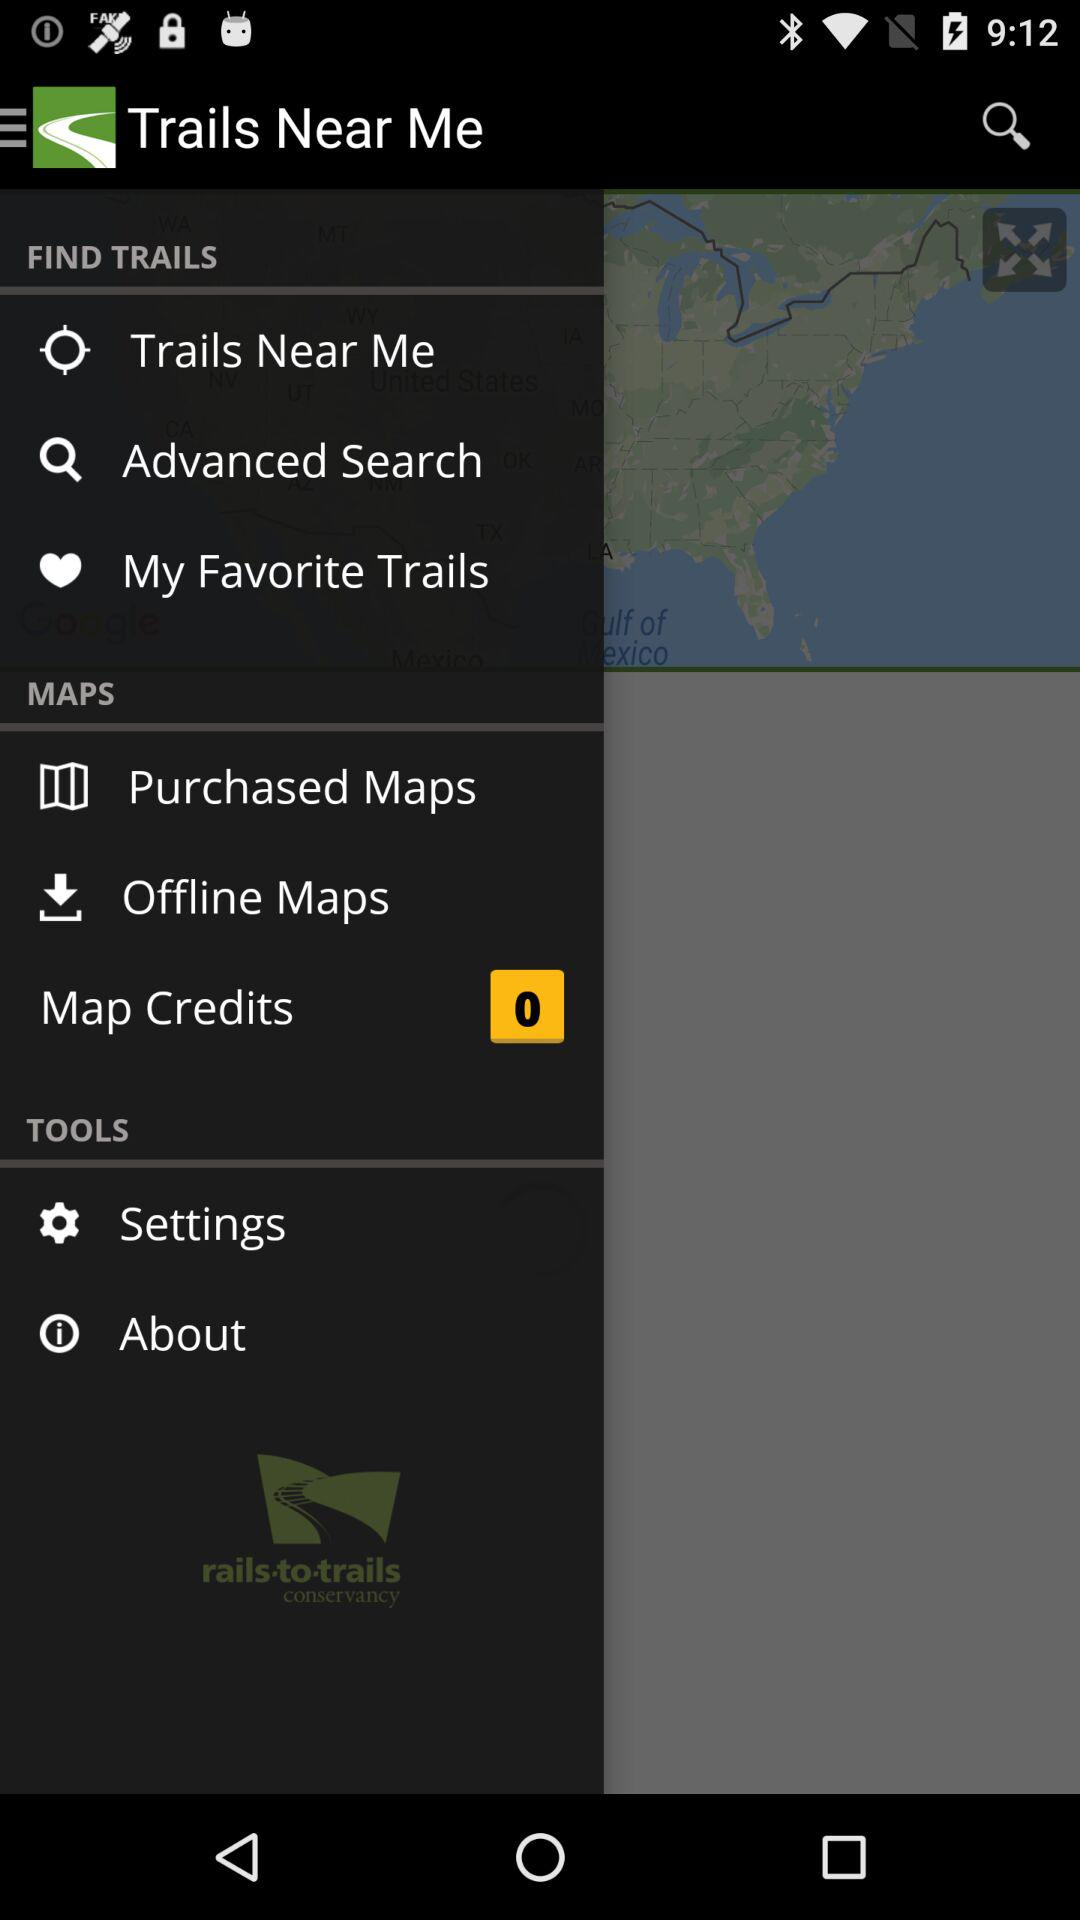What is the application name? The application name is "Trails Near Me". 